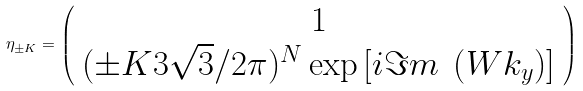Convert formula to latex. <formula><loc_0><loc_0><loc_500><loc_500>\eta _ { \pm K } = \left ( { \begin{array} { c } 1 \\ ( \pm K 3 \sqrt { 3 } / 2 \pi ) ^ { N } \exp { \left [ { i \Im m \ \left ( { W k _ { y } } \right ) } \right ] } \end{array} } \right )</formula> 